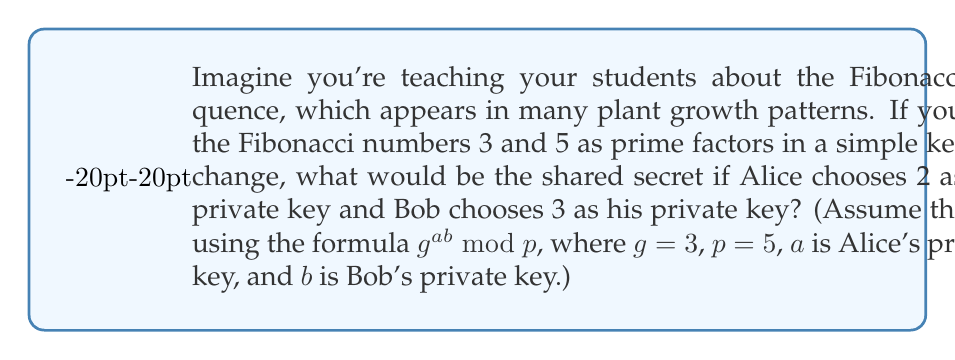Can you solve this math problem? Let's break this down step-by-step:

1) In this simple key exchange inspired by the Fibonacci sequence in plant growth, we're using:
   - $g = 3$ (the first Fibonacci prime)
   - $p = 5$ (the second Fibonacci prime)
   - $a = 2$ (Alice's private key)
   - $b = 3$ (Bob's private key)

2) The formula for the shared secret is $g^{ab} \bmod p$

3) Let's calculate this:
   $$g^{ab} \bmod p = 3^{2 \cdot 3} \bmod 5$$

4) Simplify the exponent:
   $$3^6 \bmod 5$$

5) Calculate $3^6$:
   $$3^6 = 729$$

6) Now, calculate 729 mod 5:
   $$729 \div 5 = 145 \text{ remainder } 4$$

7) Therefore, the shared secret is 4.

This mimics how plants use simple rules (like the Fibonacci sequence) to create complex patterns, just as we use simple math to create a secure shared secret!
Answer: 4 